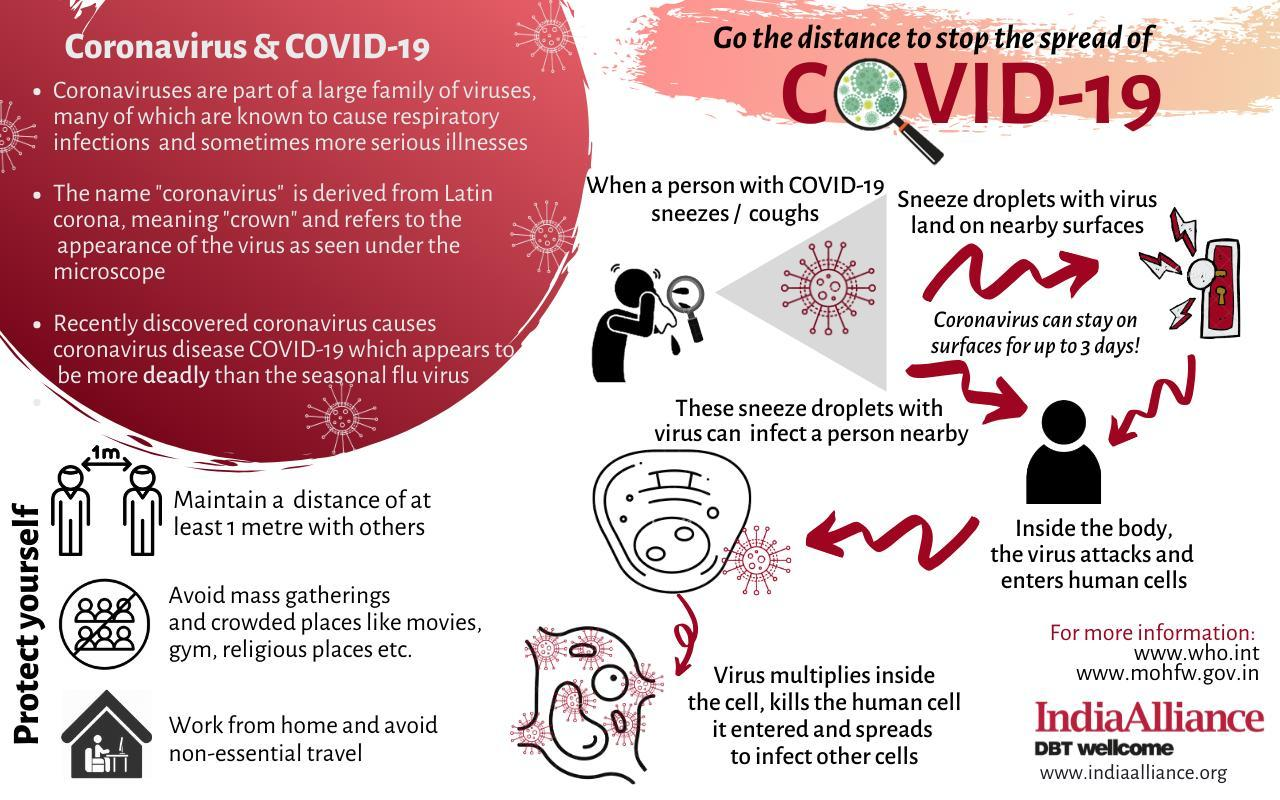How many steps to protect yourself are listed in this infographic ?
Answer the question with a short phrase. 3 The name of the virus family has originated from which language? Latin What is the average survival time of the virus on surfaces? 3 days The resemblance to what shape has given the virus family its name? crown 